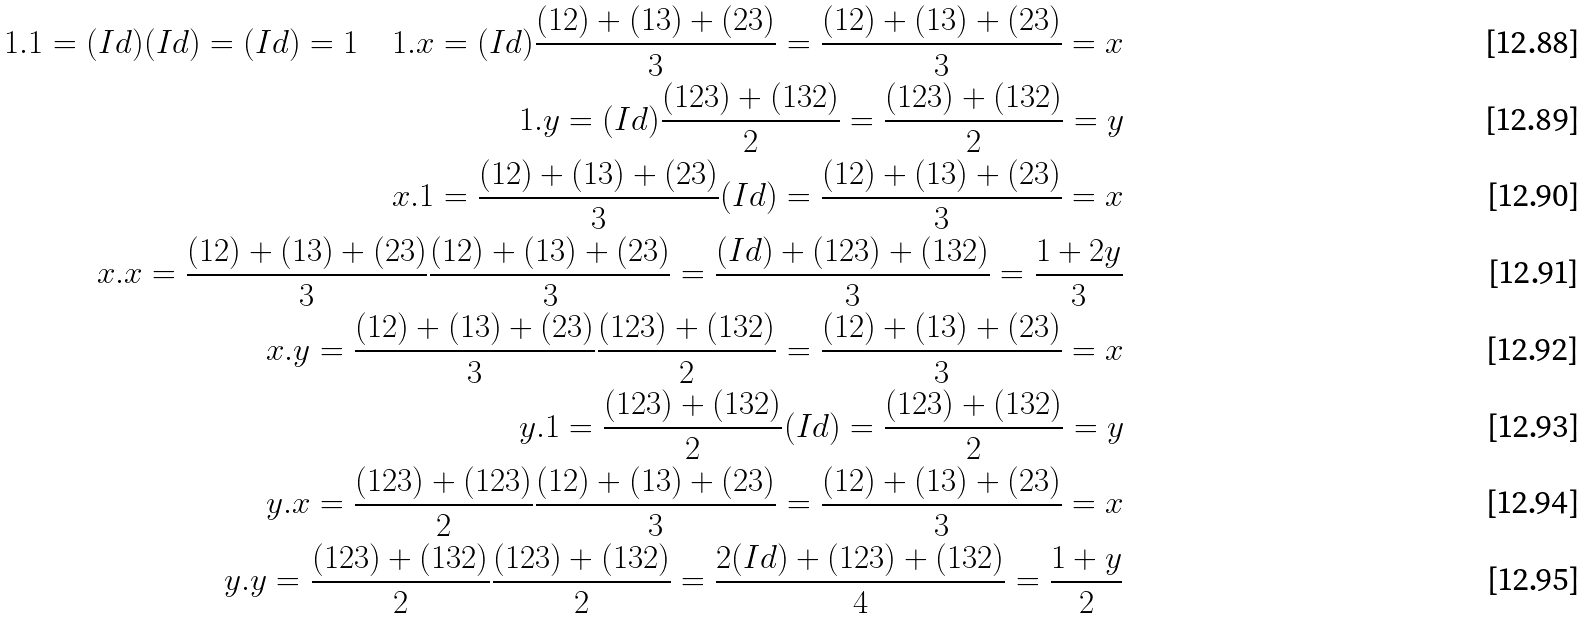Convert formula to latex. <formula><loc_0><loc_0><loc_500><loc_500>1 . 1 = ( I d ) ( I d ) = ( I d ) = 1 \quad 1 . x = ( I d ) \frac { ( 1 2 ) + ( 1 3 ) + ( 2 3 ) } { 3 } = \frac { ( 1 2 ) + ( 1 3 ) + ( 2 3 ) } { 3 } = x \\ 1 . y = ( I d ) \frac { ( 1 2 3 ) + ( 1 3 2 ) } { 2 } = \frac { ( 1 2 3 ) + ( 1 3 2 ) } { 2 } = y \\ x . 1 = \frac { ( 1 2 ) + ( 1 3 ) + ( 2 3 ) } { 3 } ( I d ) = \frac { ( 1 2 ) + ( 1 3 ) + ( 2 3 ) } { 3 } = x \\ x . x = \frac { ( 1 2 ) + ( 1 3 ) + ( 2 3 ) } { 3 } \frac { ( 1 2 ) + ( 1 3 ) + ( 2 3 ) } { 3 } = \frac { ( I d ) + ( 1 2 3 ) + ( 1 3 2 ) } { 3 } = \frac { 1 + 2 y } { 3 } \\ x . y = \frac { ( 1 2 ) + ( 1 3 ) + ( 2 3 ) } { 3 } \frac { ( 1 2 3 ) + ( 1 3 2 ) } { 2 } = \frac { ( 1 2 ) + ( 1 3 ) + ( 2 3 ) } { 3 } = x \\ y . 1 = \frac { ( 1 2 3 ) + ( 1 3 2 ) } { 2 } ( I d ) = \frac { ( 1 2 3 ) + ( 1 3 2 ) } { 2 } = y \\ y . x = \frac { ( 1 2 3 ) + ( 1 2 3 ) } { 2 } \frac { ( 1 2 ) + ( 1 3 ) + ( 2 3 ) } { 3 } = \frac { ( 1 2 ) + ( 1 3 ) + ( 2 3 ) } { 3 } = x \\ y . y = \frac { ( 1 2 3 ) + ( 1 3 2 ) } { 2 } \frac { ( 1 2 3 ) + ( 1 3 2 ) } { 2 } = \frac { 2 ( I d ) + ( 1 2 3 ) + ( 1 3 2 ) } { 4 } = \frac { 1 + y } { 2 }</formula> 